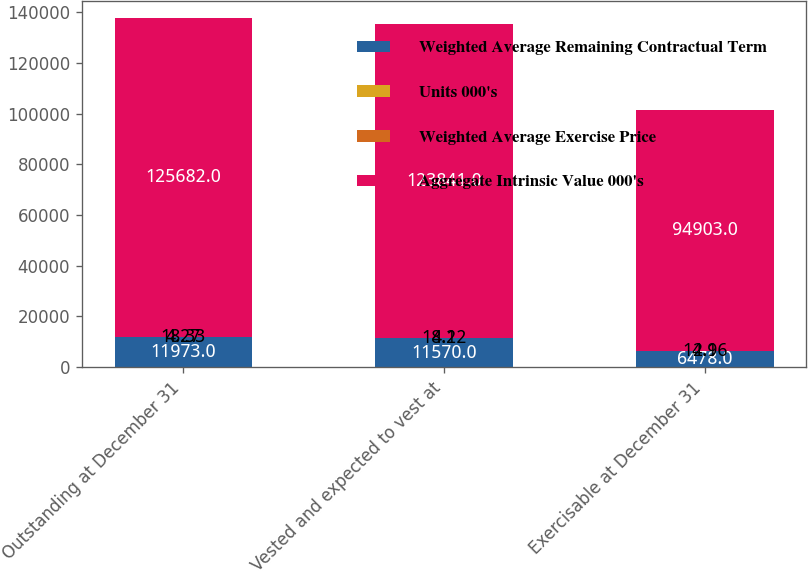Convert chart. <chart><loc_0><loc_0><loc_500><loc_500><stacked_bar_chart><ecel><fcel>Outstanding at December 31<fcel>Vested and expected to vest at<fcel>Exercisable at December 31<nl><fcel>Weighted Average Remaining Contractual Term<fcel>11973<fcel>11570<fcel>6478<nl><fcel>Units 000's<fcel>18.33<fcel>18.12<fcel>14.16<nl><fcel>Weighted Average Exercise Price<fcel>4.27<fcel>4.2<fcel>2.9<nl><fcel>Aggregate Intrinsic Value 000's<fcel>125682<fcel>123841<fcel>94903<nl></chart> 